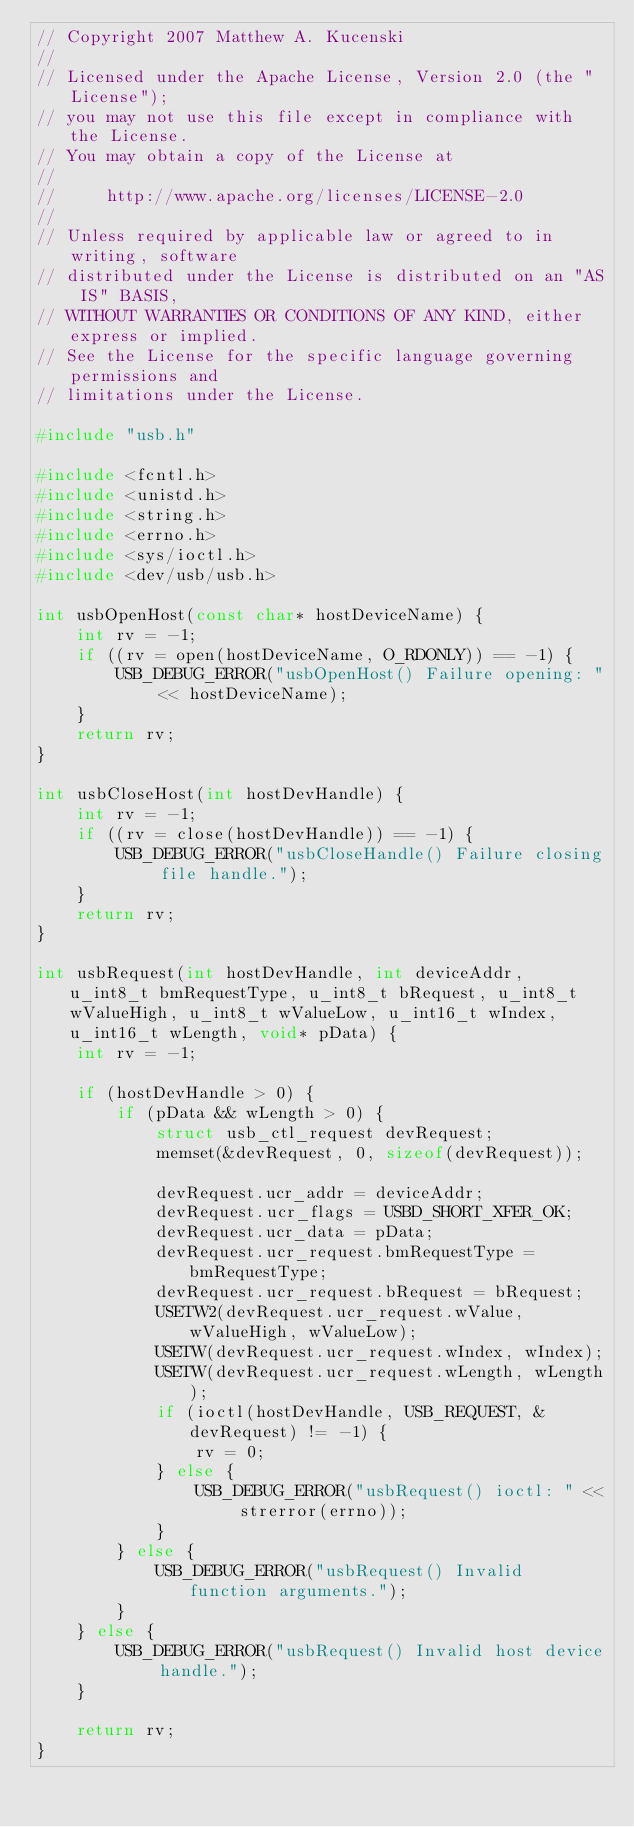Convert code to text. <code><loc_0><loc_0><loc_500><loc_500><_C++_>// Copyright 2007 Matthew A. Kucenski
//
// Licensed under the Apache License, Version 2.0 (the "License");
// you may not use this file except in compliance with the License.
// You may obtain a copy of the License at
//
//     http://www.apache.org/licenses/LICENSE-2.0
//
// Unless required by applicable law or agreed to in writing, software
// distributed under the License is distributed on an "AS IS" BASIS,
// WITHOUT WARRANTIES OR CONDITIONS OF ANY KIND, either express or implied.
// See the License for the specific language governing permissions and
// limitations under the License.

#include "usb.h"

#include <fcntl.h>
#include <unistd.h>
#include <string.h>
#include <errno.h>
#include <sys/ioctl.h>
#include <dev/usb/usb.h>

int usbOpenHost(const char* hostDeviceName) {
	int rv = -1;
	if ((rv = open(hostDeviceName, O_RDONLY)) == -1) {
		USB_DEBUG_ERROR("usbOpenHost() Failure opening: " << hostDeviceName);
	}
	return rv;
}

int usbCloseHost(int hostDevHandle) {
	int rv = -1;
	if ((rv = close(hostDevHandle)) == -1) {
		USB_DEBUG_ERROR("usbCloseHandle() Failure closing file handle.");
	}
	return rv;
}

int usbRequest(int hostDevHandle, int deviceAddr, u_int8_t bmRequestType, u_int8_t bRequest, u_int8_t wValueHigh, u_int8_t wValueLow, u_int16_t wIndex, u_int16_t wLength, void* pData) {
	int rv = -1;
	
	if (hostDevHandle > 0) {
		if (pData && wLength > 0) {
			struct usb_ctl_request devRequest;
			memset(&devRequest, 0, sizeof(devRequest));
			
			devRequest.ucr_addr = deviceAddr;
			devRequest.ucr_flags = USBD_SHORT_XFER_OK;
			devRequest.ucr_data = pData;
			devRequest.ucr_request.bmRequestType = bmRequestType;
			devRequest.ucr_request.bRequest = bRequest;
			USETW2(devRequest.ucr_request.wValue, wValueHigh, wValueLow);
			USETW(devRequest.ucr_request.wIndex, wIndex);
			USETW(devRequest.ucr_request.wLength, wLength);
			if (ioctl(hostDevHandle, USB_REQUEST, &devRequest) != -1) {
				rv = 0;
			} else {
				USB_DEBUG_ERROR("usbRequest() ioctl: " << strerror(errno));
			}
		} else {
			USB_DEBUG_ERROR("usbRequest() Invalid function arguments.");
		}
	} else {
		USB_DEBUG_ERROR("usbRequest() Invalid host device handle.");
	}
	
	return rv;
}
</code> 